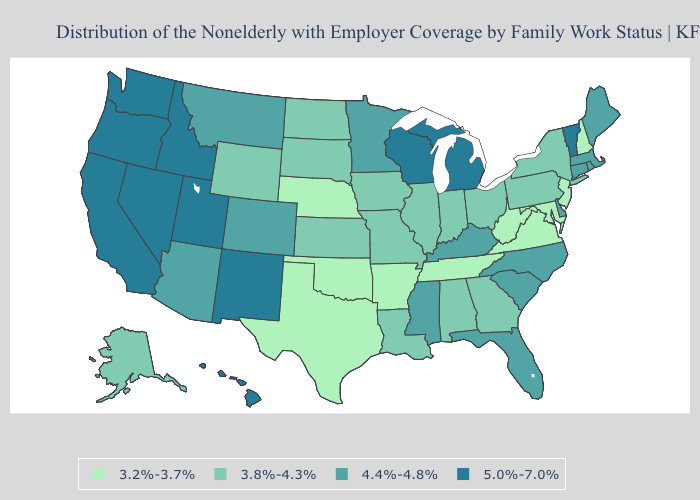Which states have the highest value in the USA?
Give a very brief answer. California, Hawaii, Idaho, Michigan, Nevada, New Mexico, Oregon, Utah, Vermont, Washington, Wisconsin. Name the states that have a value in the range 4.4%-4.8%?
Answer briefly. Arizona, Colorado, Connecticut, Delaware, Florida, Kentucky, Maine, Massachusetts, Minnesota, Mississippi, Montana, North Carolina, Rhode Island, South Carolina. What is the lowest value in the West?
Be succinct. 3.8%-4.3%. What is the value of Florida?
Be succinct. 4.4%-4.8%. Name the states that have a value in the range 3.8%-4.3%?
Answer briefly. Alabama, Alaska, Georgia, Illinois, Indiana, Iowa, Kansas, Louisiana, Missouri, New York, North Dakota, Ohio, Pennsylvania, South Dakota, Wyoming. What is the lowest value in states that border Maryland?
Quick response, please. 3.2%-3.7%. Name the states that have a value in the range 5.0%-7.0%?
Concise answer only. California, Hawaii, Idaho, Michigan, Nevada, New Mexico, Oregon, Utah, Vermont, Washington, Wisconsin. What is the value of Florida?
Keep it brief. 4.4%-4.8%. What is the highest value in states that border Maine?
Give a very brief answer. 3.2%-3.7%. What is the lowest value in the USA?
Quick response, please. 3.2%-3.7%. What is the lowest value in states that border California?
Keep it brief. 4.4%-4.8%. How many symbols are there in the legend?
Quick response, please. 4. Does New Hampshire have the lowest value in the USA?
Be succinct. Yes. Name the states that have a value in the range 4.4%-4.8%?
Keep it brief. Arizona, Colorado, Connecticut, Delaware, Florida, Kentucky, Maine, Massachusetts, Minnesota, Mississippi, Montana, North Carolina, Rhode Island, South Carolina. Does the first symbol in the legend represent the smallest category?
Answer briefly. Yes. 